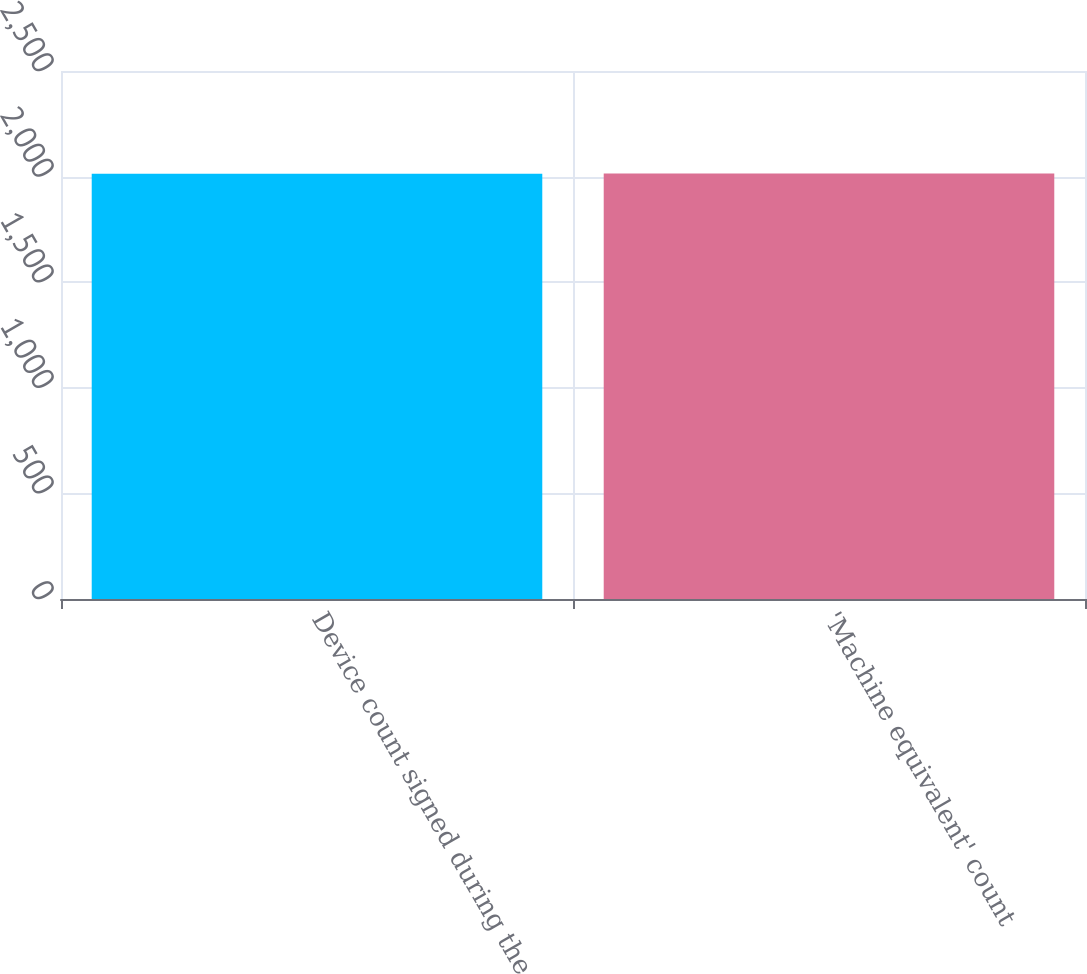<chart> <loc_0><loc_0><loc_500><loc_500><bar_chart><fcel>Device count signed during the<fcel>'Machine equivalent' count<nl><fcel>2014<fcel>2014.1<nl></chart> 